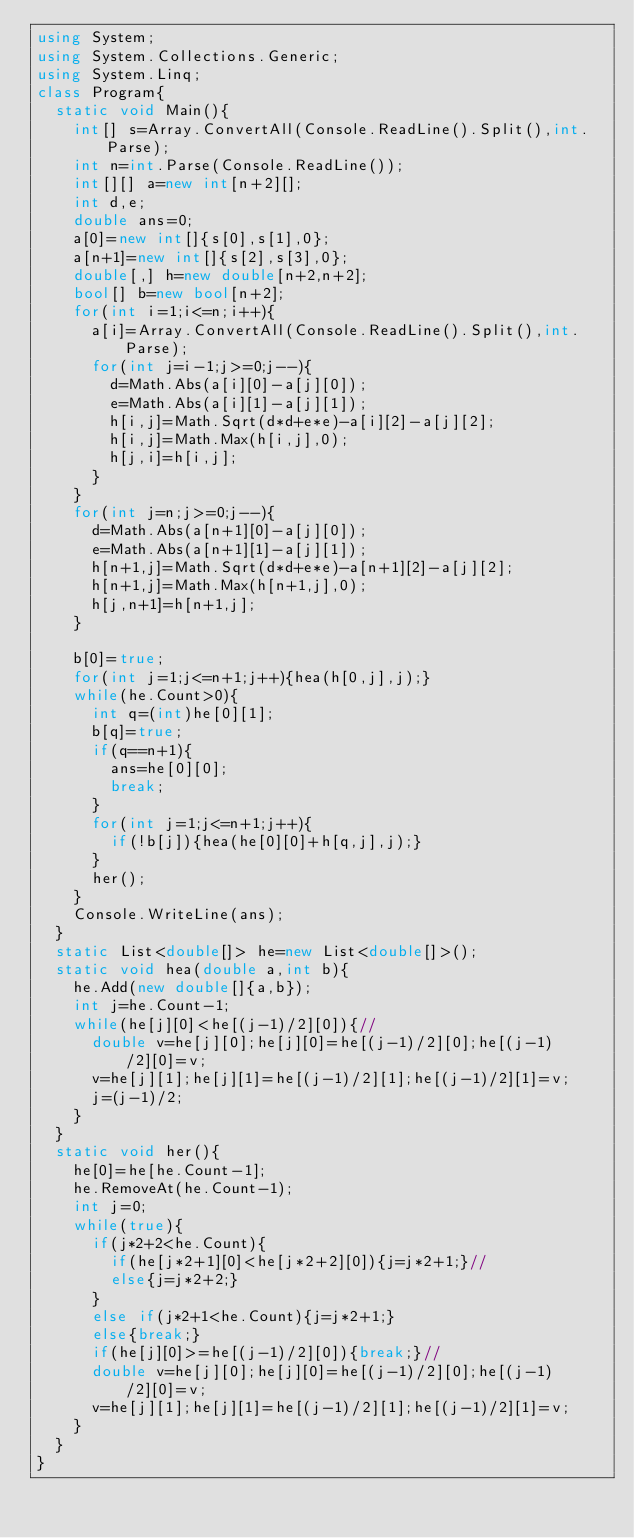<code> <loc_0><loc_0><loc_500><loc_500><_C#_>using System;
using System.Collections.Generic;
using System.Linq;
class Program{
	static void Main(){
		int[] s=Array.ConvertAll(Console.ReadLine().Split(),int.Parse);
		int n=int.Parse(Console.ReadLine());
		int[][] a=new int[n+2][];
		int d,e;
		double ans=0;
		a[0]=new int[]{s[0],s[1],0};
		a[n+1]=new int[]{s[2],s[3],0};
		double[,] h=new double[n+2,n+2];
		bool[] b=new bool[n+2];
		for(int i=1;i<=n;i++){
			a[i]=Array.ConvertAll(Console.ReadLine().Split(),int.Parse);
			for(int j=i-1;j>=0;j--){
				d=Math.Abs(a[i][0]-a[j][0]);
				e=Math.Abs(a[i][1]-a[j][1]);
				h[i,j]=Math.Sqrt(d*d+e*e)-a[i][2]-a[j][2];
				h[i,j]=Math.Max(h[i,j],0);
				h[j,i]=h[i,j];
			}
		}
		for(int j=n;j>=0;j--){
			d=Math.Abs(a[n+1][0]-a[j][0]);
			e=Math.Abs(a[n+1][1]-a[j][1]);
			h[n+1,j]=Math.Sqrt(d*d+e*e)-a[n+1][2]-a[j][2];
			h[n+1,j]=Math.Max(h[n+1,j],0);
			h[j,n+1]=h[n+1,j];
		}

		b[0]=true;
		for(int j=1;j<=n+1;j++){hea(h[0,j],j);}
		while(he.Count>0){
			int q=(int)he[0][1];
			b[q]=true;
			if(q==n+1){
				ans=he[0][0];
				break;
			}
			for(int j=1;j<=n+1;j++){
				if(!b[j]){hea(he[0][0]+h[q,j],j);}
			}
			her();
		}
		Console.WriteLine(ans);
	}
	static List<double[]> he=new List<double[]>();
	static void hea(double a,int b){
		he.Add(new double[]{a,b});
		int j=he.Count-1;
		while(he[j][0]<he[(j-1)/2][0]){//
			double v=he[j][0];he[j][0]=he[(j-1)/2][0];he[(j-1)/2][0]=v;
			v=he[j][1];he[j][1]=he[(j-1)/2][1];he[(j-1)/2][1]=v;
			j=(j-1)/2;
		}
	}
	static void her(){
		he[0]=he[he.Count-1];
		he.RemoveAt(he.Count-1);
		int j=0;
		while(true){
			if(j*2+2<he.Count){
				if(he[j*2+1][0]<he[j*2+2][0]){j=j*2+1;}//
				else{j=j*2+2;}
			}
			else if(j*2+1<he.Count){j=j*2+1;}
			else{break;}
			if(he[j][0]>=he[(j-1)/2][0]){break;}//
			double v=he[j][0];he[j][0]=he[(j-1)/2][0];he[(j-1)/2][0]=v;
			v=he[j][1];he[j][1]=he[(j-1)/2][1];he[(j-1)/2][1]=v;
		}
	}
}</code> 